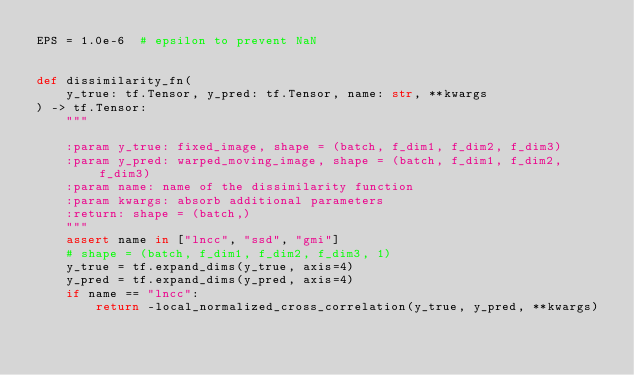Convert code to text. <code><loc_0><loc_0><loc_500><loc_500><_Python_>EPS = 1.0e-6  # epsilon to prevent NaN


def dissimilarity_fn(
    y_true: tf.Tensor, y_pred: tf.Tensor, name: str, **kwargs
) -> tf.Tensor:
    """

    :param y_true: fixed_image, shape = (batch, f_dim1, f_dim2, f_dim3)
    :param y_pred: warped_moving_image, shape = (batch, f_dim1, f_dim2, f_dim3)
    :param name: name of the dissimilarity function
    :param kwargs: absorb additional parameters
    :return: shape = (batch,)
    """
    assert name in ["lncc", "ssd", "gmi"]
    # shape = (batch, f_dim1, f_dim2, f_dim3, 1)
    y_true = tf.expand_dims(y_true, axis=4)
    y_pred = tf.expand_dims(y_pred, axis=4)
    if name == "lncc":
        return -local_normalized_cross_correlation(y_true, y_pred, **kwargs)</code> 